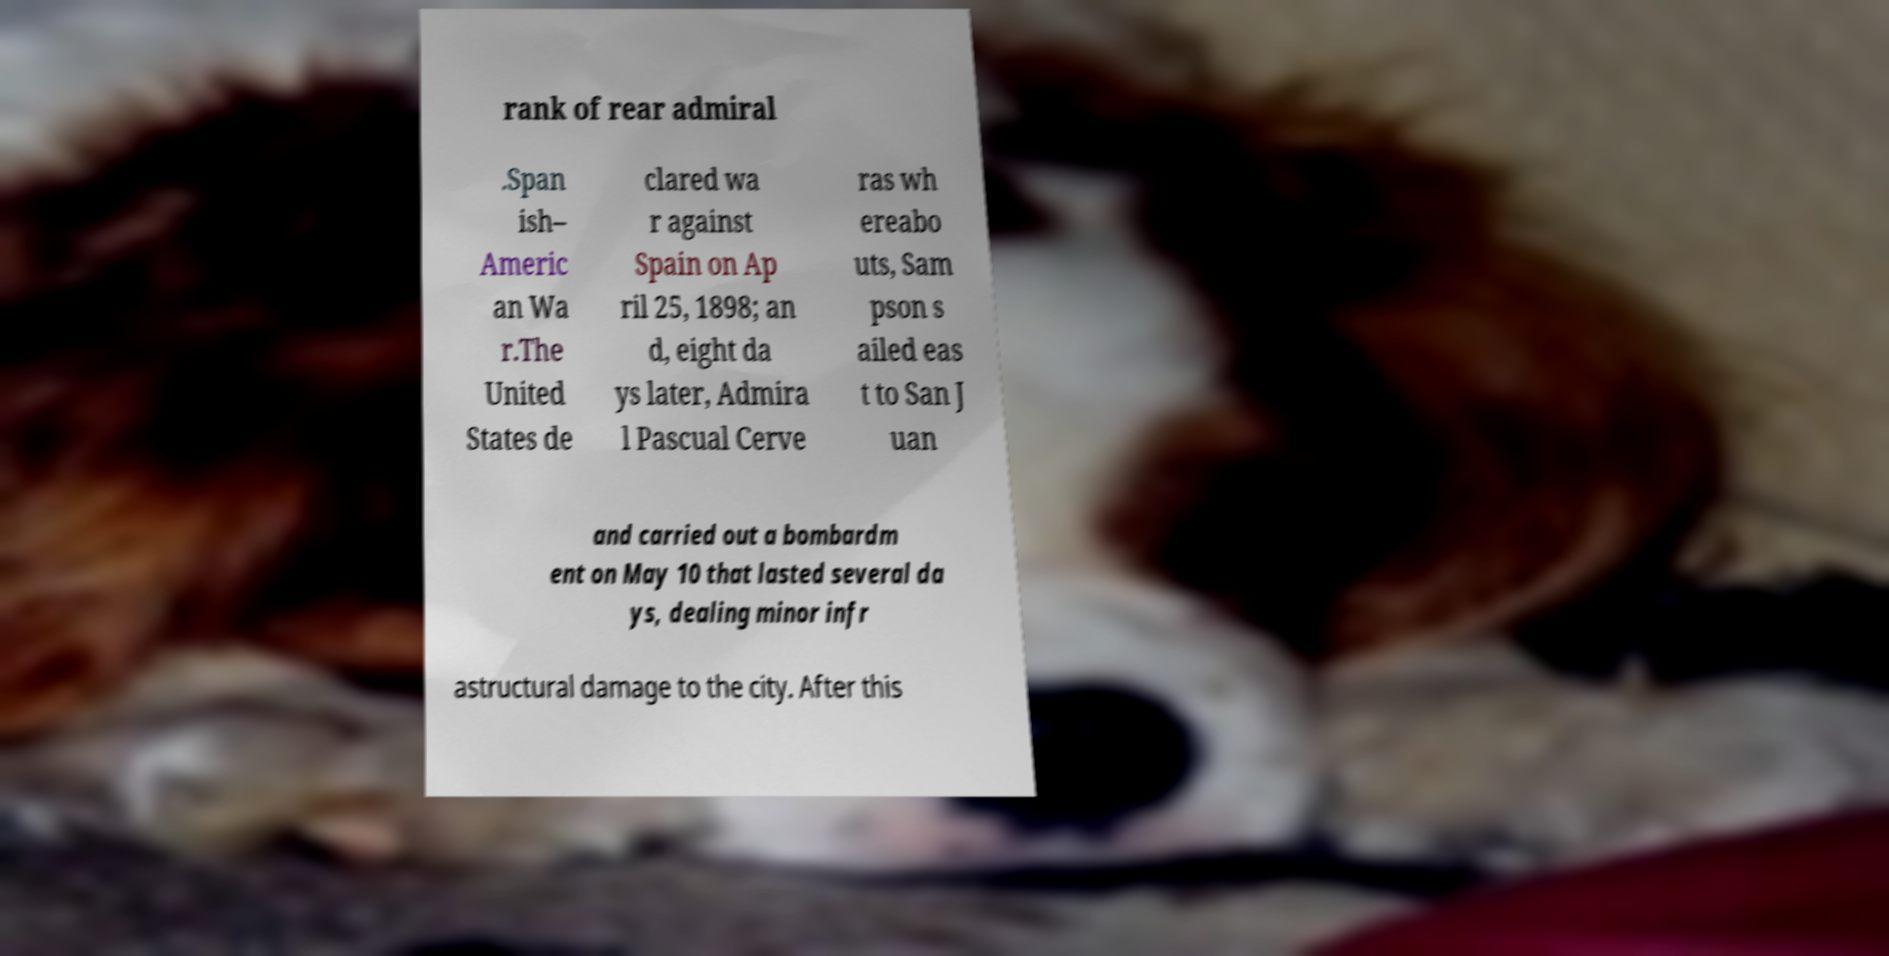What messages or text are displayed in this image? I need them in a readable, typed format. rank of rear admiral .Span ish– Americ an Wa r.The United States de clared wa r against Spain on Ap ril 25, 1898; an d, eight da ys later, Admira l Pascual Cerve ras wh ereabo uts, Sam pson s ailed eas t to San J uan and carried out a bombardm ent on May 10 that lasted several da ys, dealing minor infr astructural damage to the city. After this 